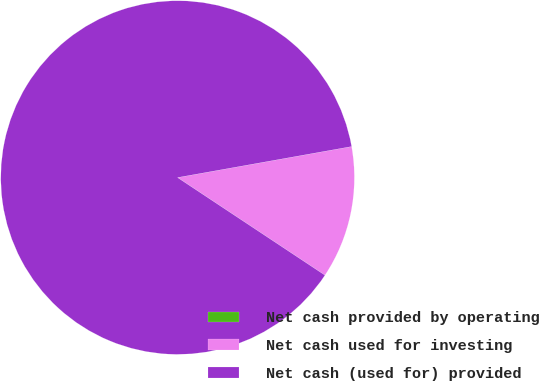<chart> <loc_0><loc_0><loc_500><loc_500><pie_chart><fcel>Net cash provided by operating<fcel>Net cash used for investing<fcel>Net cash (used for) provided<nl><fcel>0.0%<fcel>12.12%<fcel>87.88%<nl></chart> 